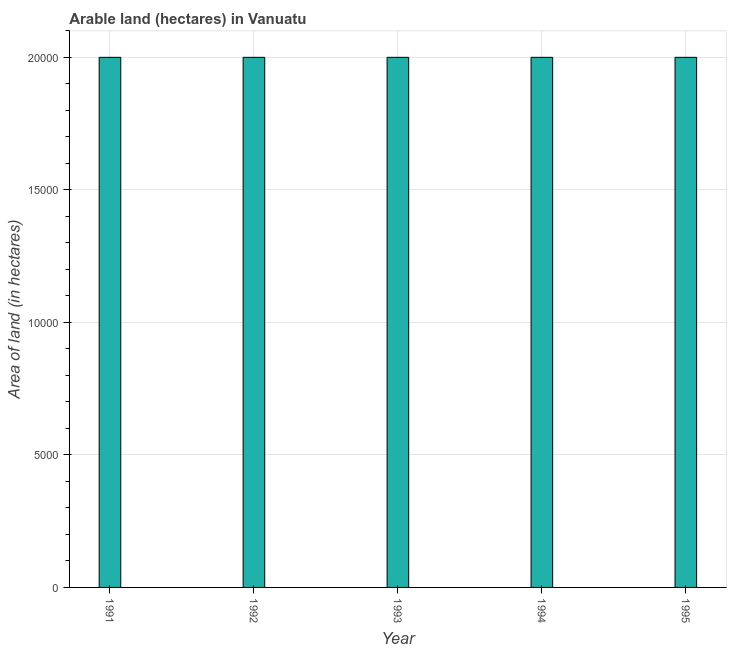Does the graph contain any zero values?
Offer a terse response. No. Does the graph contain grids?
Keep it short and to the point. Yes. What is the title of the graph?
Keep it short and to the point. Arable land (hectares) in Vanuatu. What is the label or title of the Y-axis?
Your answer should be compact. Area of land (in hectares). Across all years, what is the minimum area of land?
Provide a succinct answer. 2.00e+04. In which year was the area of land maximum?
Offer a terse response. 1991. In which year was the area of land minimum?
Keep it short and to the point. 1991. What is the sum of the area of land?
Give a very brief answer. 1.00e+05. What is the average area of land per year?
Your answer should be very brief. 2.00e+04. In how many years, is the area of land greater than 17000 hectares?
Your response must be concise. 5. Do a majority of the years between 1991 and 1995 (inclusive) have area of land greater than 2000 hectares?
Your answer should be very brief. Yes. What is the ratio of the area of land in 1991 to that in 1993?
Make the answer very short. 1. Is the area of land in 1992 less than that in 1994?
Your response must be concise. No. What is the difference between the highest and the second highest area of land?
Your response must be concise. 0. Is the sum of the area of land in 1991 and 1993 greater than the maximum area of land across all years?
Give a very brief answer. Yes. What is the difference between the highest and the lowest area of land?
Make the answer very short. 0. Are all the bars in the graph horizontal?
Give a very brief answer. No. What is the difference between two consecutive major ticks on the Y-axis?
Your answer should be compact. 5000. What is the Area of land (in hectares) in 1992?
Give a very brief answer. 2.00e+04. What is the Area of land (in hectares) of 1993?
Your answer should be compact. 2.00e+04. What is the Area of land (in hectares) in 1994?
Provide a short and direct response. 2.00e+04. What is the difference between the Area of land (in hectares) in 1991 and 1993?
Your response must be concise. 0. What is the difference between the Area of land (in hectares) in 1991 and 1995?
Offer a terse response. 0. What is the difference between the Area of land (in hectares) in 1992 and 1993?
Your answer should be compact. 0. What is the difference between the Area of land (in hectares) in 1992 and 1994?
Offer a terse response. 0. What is the difference between the Area of land (in hectares) in 1992 and 1995?
Provide a short and direct response. 0. What is the difference between the Area of land (in hectares) in 1993 and 1994?
Offer a very short reply. 0. What is the difference between the Area of land (in hectares) in 1993 and 1995?
Ensure brevity in your answer.  0. What is the ratio of the Area of land (in hectares) in 1991 to that in 1992?
Provide a short and direct response. 1. What is the ratio of the Area of land (in hectares) in 1993 to that in 1994?
Give a very brief answer. 1. What is the ratio of the Area of land (in hectares) in 1993 to that in 1995?
Give a very brief answer. 1. 